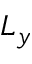<formula> <loc_0><loc_0><loc_500><loc_500>L _ { y }</formula> 